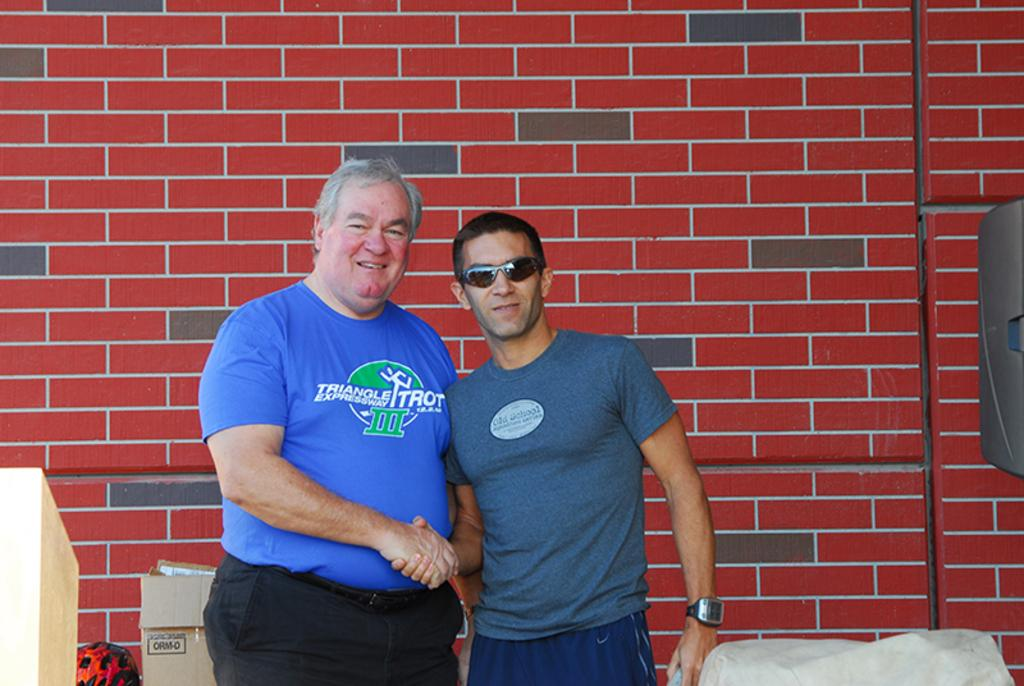How many people are in the image? There are two men in the image. What is one of the men wearing? One of the men is wearing goggles. What object can be seen in the image besides the men? There is a box in the image. What can be seen in the background of the image? There is a wall in the background of the image. What type of appliance is growing on the wall in the image? There is no appliance growing on the wall in the image; the wall is a part of the background and does not have any appliances or growth visible. --- 